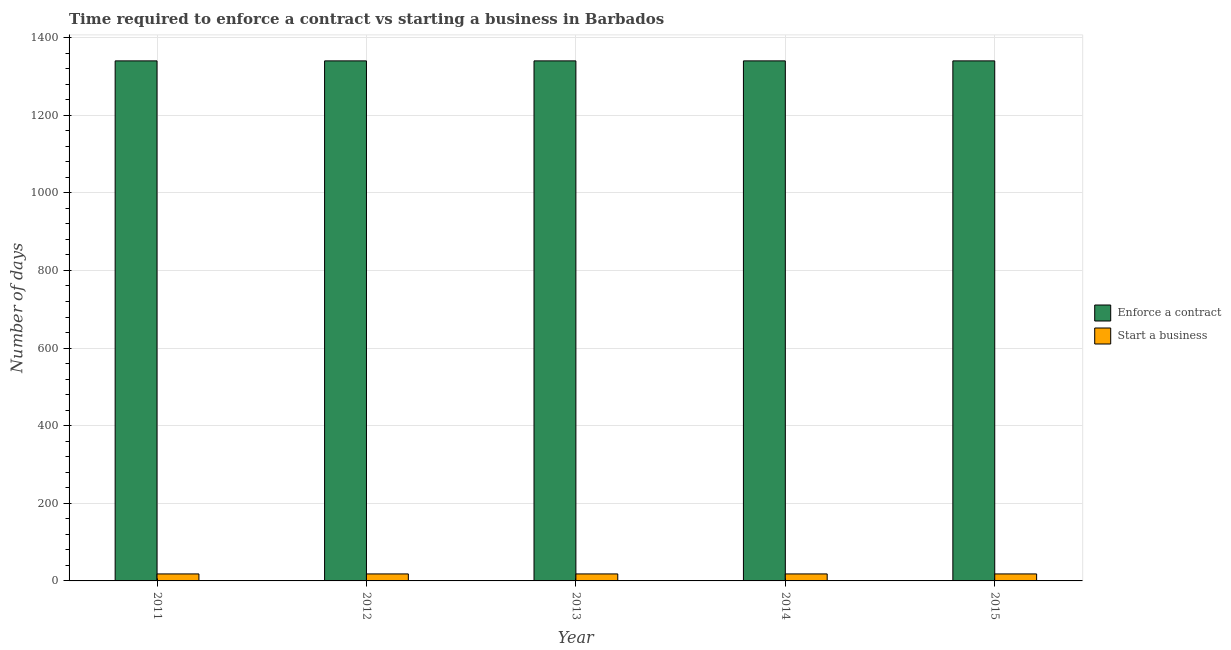Are the number of bars per tick equal to the number of legend labels?
Give a very brief answer. Yes. Are the number of bars on each tick of the X-axis equal?
Ensure brevity in your answer.  Yes. How many bars are there on the 1st tick from the left?
Provide a succinct answer. 2. What is the label of the 2nd group of bars from the left?
Make the answer very short. 2012. In how many cases, is the number of bars for a given year not equal to the number of legend labels?
Provide a succinct answer. 0. What is the number of days to start a business in 2013?
Your answer should be compact. 18. Across all years, what is the maximum number of days to start a business?
Your answer should be very brief. 18. Across all years, what is the minimum number of days to enforece a contract?
Your response must be concise. 1340. In which year was the number of days to enforece a contract maximum?
Your answer should be compact. 2011. In which year was the number of days to enforece a contract minimum?
Your answer should be compact. 2011. What is the total number of days to enforece a contract in the graph?
Your answer should be compact. 6700. What is the difference between the number of days to start a business in 2011 and the number of days to enforece a contract in 2012?
Ensure brevity in your answer.  0. What is the average number of days to enforece a contract per year?
Your answer should be compact. 1340. In the year 2013, what is the difference between the number of days to start a business and number of days to enforece a contract?
Give a very brief answer. 0. In how many years, is the number of days to start a business greater than 160 days?
Provide a short and direct response. 0. Is the difference between the number of days to start a business in 2012 and 2013 greater than the difference between the number of days to enforece a contract in 2012 and 2013?
Give a very brief answer. No. What is the difference between the highest and the lowest number of days to start a business?
Offer a very short reply. 0. Is the sum of the number of days to start a business in 2012 and 2014 greater than the maximum number of days to enforece a contract across all years?
Your answer should be very brief. Yes. What does the 1st bar from the left in 2011 represents?
Provide a short and direct response. Enforce a contract. What does the 1st bar from the right in 2015 represents?
Your response must be concise. Start a business. How many bars are there?
Ensure brevity in your answer.  10. Are all the bars in the graph horizontal?
Your answer should be compact. No. How many years are there in the graph?
Your response must be concise. 5. What is the difference between two consecutive major ticks on the Y-axis?
Provide a short and direct response. 200. Are the values on the major ticks of Y-axis written in scientific E-notation?
Keep it short and to the point. No. Does the graph contain any zero values?
Your response must be concise. No. Does the graph contain grids?
Offer a very short reply. Yes. How are the legend labels stacked?
Your answer should be compact. Vertical. What is the title of the graph?
Offer a very short reply. Time required to enforce a contract vs starting a business in Barbados. What is the label or title of the X-axis?
Your response must be concise. Year. What is the label or title of the Y-axis?
Give a very brief answer. Number of days. What is the Number of days in Enforce a contract in 2011?
Provide a succinct answer. 1340. What is the Number of days of Start a business in 2011?
Give a very brief answer. 18. What is the Number of days in Enforce a contract in 2012?
Offer a terse response. 1340. What is the Number of days of Enforce a contract in 2013?
Your answer should be compact. 1340. What is the Number of days in Enforce a contract in 2014?
Your answer should be very brief. 1340. What is the Number of days in Enforce a contract in 2015?
Ensure brevity in your answer.  1340. Across all years, what is the maximum Number of days in Enforce a contract?
Offer a very short reply. 1340. Across all years, what is the maximum Number of days of Start a business?
Your answer should be compact. 18. Across all years, what is the minimum Number of days in Enforce a contract?
Provide a succinct answer. 1340. Across all years, what is the minimum Number of days in Start a business?
Keep it short and to the point. 18. What is the total Number of days of Enforce a contract in the graph?
Ensure brevity in your answer.  6700. What is the difference between the Number of days in Start a business in 2011 and that in 2012?
Offer a very short reply. 0. What is the difference between the Number of days of Enforce a contract in 2011 and that in 2013?
Keep it short and to the point. 0. What is the difference between the Number of days in Enforce a contract in 2011 and that in 2015?
Make the answer very short. 0. What is the difference between the Number of days in Enforce a contract in 2012 and that in 2013?
Provide a succinct answer. 0. What is the difference between the Number of days of Start a business in 2012 and that in 2014?
Keep it short and to the point. 0. What is the difference between the Number of days in Start a business in 2012 and that in 2015?
Your response must be concise. 0. What is the difference between the Number of days of Enforce a contract in 2013 and that in 2015?
Your answer should be compact. 0. What is the difference between the Number of days of Start a business in 2014 and that in 2015?
Make the answer very short. 0. What is the difference between the Number of days in Enforce a contract in 2011 and the Number of days in Start a business in 2012?
Keep it short and to the point. 1322. What is the difference between the Number of days of Enforce a contract in 2011 and the Number of days of Start a business in 2013?
Make the answer very short. 1322. What is the difference between the Number of days of Enforce a contract in 2011 and the Number of days of Start a business in 2014?
Provide a succinct answer. 1322. What is the difference between the Number of days in Enforce a contract in 2011 and the Number of days in Start a business in 2015?
Provide a short and direct response. 1322. What is the difference between the Number of days in Enforce a contract in 2012 and the Number of days in Start a business in 2013?
Your answer should be very brief. 1322. What is the difference between the Number of days in Enforce a contract in 2012 and the Number of days in Start a business in 2014?
Offer a terse response. 1322. What is the difference between the Number of days in Enforce a contract in 2012 and the Number of days in Start a business in 2015?
Ensure brevity in your answer.  1322. What is the difference between the Number of days of Enforce a contract in 2013 and the Number of days of Start a business in 2014?
Make the answer very short. 1322. What is the difference between the Number of days of Enforce a contract in 2013 and the Number of days of Start a business in 2015?
Give a very brief answer. 1322. What is the difference between the Number of days in Enforce a contract in 2014 and the Number of days in Start a business in 2015?
Offer a terse response. 1322. What is the average Number of days in Enforce a contract per year?
Give a very brief answer. 1340. What is the average Number of days in Start a business per year?
Give a very brief answer. 18. In the year 2011, what is the difference between the Number of days in Enforce a contract and Number of days in Start a business?
Your answer should be very brief. 1322. In the year 2012, what is the difference between the Number of days in Enforce a contract and Number of days in Start a business?
Your answer should be very brief. 1322. In the year 2013, what is the difference between the Number of days of Enforce a contract and Number of days of Start a business?
Keep it short and to the point. 1322. In the year 2014, what is the difference between the Number of days of Enforce a contract and Number of days of Start a business?
Make the answer very short. 1322. In the year 2015, what is the difference between the Number of days of Enforce a contract and Number of days of Start a business?
Provide a succinct answer. 1322. What is the ratio of the Number of days in Start a business in 2011 to that in 2012?
Offer a very short reply. 1. What is the ratio of the Number of days of Enforce a contract in 2011 to that in 2013?
Offer a very short reply. 1. What is the ratio of the Number of days of Enforce a contract in 2011 to that in 2014?
Offer a very short reply. 1. What is the ratio of the Number of days of Start a business in 2011 to that in 2014?
Your answer should be very brief. 1. What is the ratio of the Number of days in Enforce a contract in 2012 to that in 2013?
Provide a short and direct response. 1. What is the ratio of the Number of days of Enforce a contract in 2012 to that in 2014?
Make the answer very short. 1. What is the ratio of the Number of days of Start a business in 2012 to that in 2015?
Your answer should be very brief. 1. What is the ratio of the Number of days of Enforce a contract in 2013 to that in 2015?
Make the answer very short. 1. What is the ratio of the Number of days of Start a business in 2013 to that in 2015?
Make the answer very short. 1. What is the ratio of the Number of days of Enforce a contract in 2014 to that in 2015?
Give a very brief answer. 1. What is the difference between the highest and the second highest Number of days of Enforce a contract?
Provide a succinct answer. 0. What is the difference between the highest and the lowest Number of days in Enforce a contract?
Your answer should be very brief. 0. 